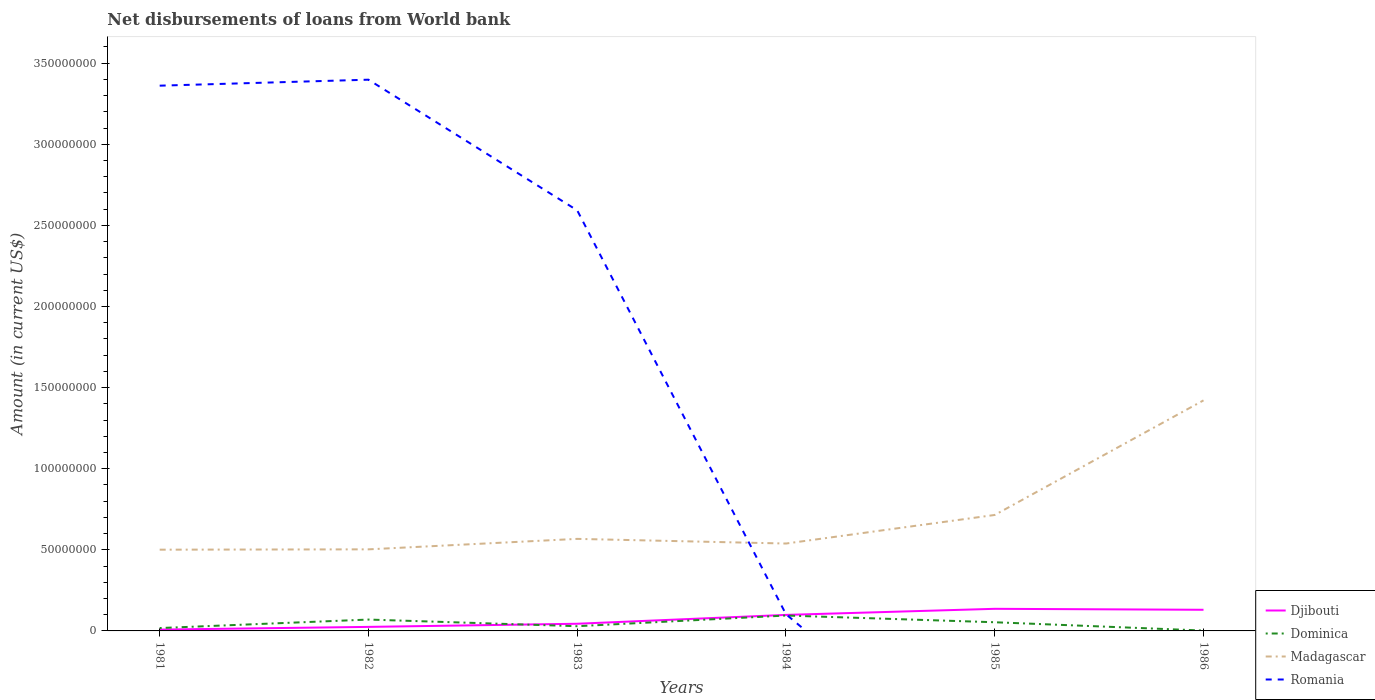Does the line corresponding to Madagascar intersect with the line corresponding to Dominica?
Keep it short and to the point. No. Is the number of lines equal to the number of legend labels?
Keep it short and to the point. No. Across all years, what is the maximum amount of loan disbursed from World Bank in Madagascar?
Give a very brief answer. 5.01e+07. What is the total amount of loan disbursed from World Bank in Dominica in the graph?
Provide a succinct answer. 2.68e+06. What is the difference between the highest and the second highest amount of loan disbursed from World Bank in Dominica?
Offer a very short reply. 9.27e+06. What is the difference between two consecutive major ticks on the Y-axis?
Your answer should be compact. 5.00e+07. Does the graph contain grids?
Your answer should be compact. No. What is the title of the graph?
Provide a short and direct response. Net disbursements of loans from World bank. What is the label or title of the X-axis?
Provide a short and direct response. Years. What is the Amount (in current US$) in Djibouti in 1981?
Keep it short and to the point. 8.20e+05. What is the Amount (in current US$) of Dominica in 1981?
Make the answer very short. 1.77e+06. What is the Amount (in current US$) in Madagascar in 1981?
Provide a succinct answer. 5.01e+07. What is the Amount (in current US$) in Romania in 1981?
Offer a terse response. 3.36e+08. What is the Amount (in current US$) in Djibouti in 1982?
Your answer should be compact. 2.48e+06. What is the Amount (in current US$) of Dominica in 1982?
Offer a terse response. 7.01e+06. What is the Amount (in current US$) of Madagascar in 1982?
Provide a short and direct response. 5.03e+07. What is the Amount (in current US$) in Romania in 1982?
Provide a short and direct response. 3.40e+08. What is the Amount (in current US$) of Djibouti in 1983?
Provide a succinct answer. 4.42e+06. What is the Amount (in current US$) in Dominica in 1983?
Give a very brief answer. 2.90e+06. What is the Amount (in current US$) of Madagascar in 1983?
Provide a short and direct response. 5.67e+07. What is the Amount (in current US$) of Romania in 1983?
Give a very brief answer. 2.59e+08. What is the Amount (in current US$) of Djibouti in 1984?
Your answer should be very brief. 9.88e+06. What is the Amount (in current US$) in Dominica in 1984?
Keep it short and to the point. 9.49e+06. What is the Amount (in current US$) of Madagascar in 1984?
Your answer should be compact. 5.39e+07. What is the Amount (in current US$) in Romania in 1984?
Offer a terse response. 1.03e+07. What is the Amount (in current US$) of Djibouti in 1985?
Your response must be concise. 1.36e+07. What is the Amount (in current US$) in Dominica in 1985?
Offer a very short reply. 5.35e+06. What is the Amount (in current US$) in Madagascar in 1985?
Offer a terse response. 7.15e+07. What is the Amount (in current US$) in Romania in 1985?
Offer a terse response. 0. What is the Amount (in current US$) of Djibouti in 1986?
Ensure brevity in your answer.  1.30e+07. What is the Amount (in current US$) of Dominica in 1986?
Make the answer very short. 2.25e+05. What is the Amount (in current US$) in Madagascar in 1986?
Your answer should be compact. 1.42e+08. Across all years, what is the maximum Amount (in current US$) in Djibouti?
Provide a short and direct response. 1.36e+07. Across all years, what is the maximum Amount (in current US$) in Dominica?
Ensure brevity in your answer.  9.49e+06. Across all years, what is the maximum Amount (in current US$) of Madagascar?
Your answer should be compact. 1.42e+08. Across all years, what is the maximum Amount (in current US$) in Romania?
Your response must be concise. 3.40e+08. Across all years, what is the minimum Amount (in current US$) of Djibouti?
Make the answer very short. 8.20e+05. Across all years, what is the minimum Amount (in current US$) in Dominica?
Make the answer very short. 2.25e+05. Across all years, what is the minimum Amount (in current US$) of Madagascar?
Keep it short and to the point. 5.01e+07. What is the total Amount (in current US$) of Djibouti in the graph?
Your answer should be very brief. 4.43e+07. What is the total Amount (in current US$) in Dominica in the graph?
Provide a succinct answer. 2.67e+07. What is the total Amount (in current US$) in Madagascar in the graph?
Ensure brevity in your answer.  4.25e+08. What is the total Amount (in current US$) in Romania in the graph?
Provide a succinct answer. 9.46e+08. What is the difference between the Amount (in current US$) of Djibouti in 1981 and that in 1982?
Ensure brevity in your answer.  -1.66e+06. What is the difference between the Amount (in current US$) of Dominica in 1981 and that in 1982?
Your answer should be compact. -5.24e+06. What is the difference between the Amount (in current US$) in Madagascar in 1981 and that in 1982?
Provide a short and direct response. -2.01e+05. What is the difference between the Amount (in current US$) of Romania in 1981 and that in 1982?
Give a very brief answer. -3.68e+06. What is the difference between the Amount (in current US$) of Djibouti in 1981 and that in 1983?
Your answer should be very brief. -3.60e+06. What is the difference between the Amount (in current US$) of Dominica in 1981 and that in 1983?
Ensure brevity in your answer.  -1.14e+06. What is the difference between the Amount (in current US$) in Madagascar in 1981 and that in 1983?
Your answer should be very brief. -6.66e+06. What is the difference between the Amount (in current US$) of Romania in 1981 and that in 1983?
Make the answer very short. 7.69e+07. What is the difference between the Amount (in current US$) in Djibouti in 1981 and that in 1984?
Your response must be concise. -9.06e+06. What is the difference between the Amount (in current US$) in Dominica in 1981 and that in 1984?
Keep it short and to the point. -7.73e+06. What is the difference between the Amount (in current US$) in Madagascar in 1981 and that in 1984?
Your response must be concise. -3.78e+06. What is the difference between the Amount (in current US$) in Romania in 1981 and that in 1984?
Your answer should be very brief. 3.26e+08. What is the difference between the Amount (in current US$) of Djibouti in 1981 and that in 1985?
Give a very brief answer. -1.28e+07. What is the difference between the Amount (in current US$) in Dominica in 1981 and that in 1985?
Your answer should be compact. -3.58e+06. What is the difference between the Amount (in current US$) of Madagascar in 1981 and that in 1985?
Provide a short and direct response. -2.14e+07. What is the difference between the Amount (in current US$) in Djibouti in 1981 and that in 1986?
Keep it short and to the point. -1.22e+07. What is the difference between the Amount (in current US$) in Dominica in 1981 and that in 1986?
Make the answer very short. 1.54e+06. What is the difference between the Amount (in current US$) of Madagascar in 1981 and that in 1986?
Your answer should be very brief. -9.20e+07. What is the difference between the Amount (in current US$) in Djibouti in 1982 and that in 1983?
Offer a terse response. -1.94e+06. What is the difference between the Amount (in current US$) of Dominica in 1982 and that in 1983?
Give a very brief answer. 4.10e+06. What is the difference between the Amount (in current US$) in Madagascar in 1982 and that in 1983?
Give a very brief answer. -6.45e+06. What is the difference between the Amount (in current US$) in Romania in 1982 and that in 1983?
Provide a short and direct response. 8.06e+07. What is the difference between the Amount (in current US$) of Djibouti in 1982 and that in 1984?
Ensure brevity in your answer.  -7.40e+06. What is the difference between the Amount (in current US$) of Dominica in 1982 and that in 1984?
Keep it short and to the point. -2.49e+06. What is the difference between the Amount (in current US$) of Madagascar in 1982 and that in 1984?
Ensure brevity in your answer.  -3.58e+06. What is the difference between the Amount (in current US$) in Romania in 1982 and that in 1984?
Provide a succinct answer. 3.30e+08. What is the difference between the Amount (in current US$) in Djibouti in 1982 and that in 1985?
Your answer should be compact. -1.11e+07. What is the difference between the Amount (in current US$) of Dominica in 1982 and that in 1985?
Keep it short and to the point. 1.66e+06. What is the difference between the Amount (in current US$) in Madagascar in 1982 and that in 1985?
Your answer should be very brief. -2.12e+07. What is the difference between the Amount (in current US$) of Djibouti in 1982 and that in 1986?
Provide a short and direct response. -1.06e+07. What is the difference between the Amount (in current US$) in Dominica in 1982 and that in 1986?
Provide a succinct answer. 6.78e+06. What is the difference between the Amount (in current US$) in Madagascar in 1982 and that in 1986?
Give a very brief answer. -9.18e+07. What is the difference between the Amount (in current US$) of Djibouti in 1983 and that in 1984?
Keep it short and to the point. -5.46e+06. What is the difference between the Amount (in current US$) in Dominica in 1983 and that in 1984?
Make the answer very short. -6.59e+06. What is the difference between the Amount (in current US$) of Madagascar in 1983 and that in 1984?
Your answer should be compact. 2.87e+06. What is the difference between the Amount (in current US$) in Romania in 1983 and that in 1984?
Your answer should be very brief. 2.49e+08. What is the difference between the Amount (in current US$) in Djibouti in 1983 and that in 1985?
Your answer should be compact. -9.21e+06. What is the difference between the Amount (in current US$) of Dominica in 1983 and that in 1985?
Your answer should be compact. -2.44e+06. What is the difference between the Amount (in current US$) of Madagascar in 1983 and that in 1985?
Your response must be concise. -1.47e+07. What is the difference between the Amount (in current US$) of Djibouti in 1983 and that in 1986?
Your answer should be compact. -8.62e+06. What is the difference between the Amount (in current US$) in Dominica in 1983 and that in 1986?
Provide a short and direct response. 2.68e+06. What is the difference between the Amount (in current US$) of Madagascar in 1983 and that in 1986?
Offer a very short reply. -8.54e+07. What is the difference between the Amount (in current US$) of Djibouti in 1984 and that in 1985?
Your answer should be very brief. -3.75e+06. What is the difference between the Amount (in current US$) of Dominica in 1984 and that in 1985?
Your answer should be very brief. 4.15e+06. What is the difference between the Amount (in current US$) in Madagascar in 1984 and that in 1985?
Ensure brevity in your answer.  -1.76e+07. What is the difference between the Amount (in current US$) in Djibouti in 1984 and that in 1986?
Ensure brevity in your answer.  -3.16e+06. What is the difference between the Amount (in current US$) of Dominica in 1984 and that in 1986?
Give a very brief answer. 9.27e+06. What is the difference between the Amount (in current US$) in Madagascar in 1984 and that in 1986?
Give a very brief answer. -8.83e+07. What is the difference between the Amount (in current US$) in Djibouti in 1985 and that in 1986?
Keep it short and to the point. 5.93e+05. What is the difference between the Amount (in current US$) in Dominica in 1985 and that in 1986?
Your response must be concise. 5.12e+06. What is the difference between the Amount (in current US$) of Madagascar in 1985 and that in 1986?
Give a very brief answer. -7.06e+07. What is the difference between the Amount (in current US$) in Djibouti in 1981 and the Amount (in current US$) in Dominica in 1982?
Provide a short and direct response. -6.19e+06. What is the difference between the Amount (in current US$) in Djibouti in 1981 and the Amount (in current US$) in Madagascar in 1982?
Provide a short and direct response. -4.95e+07. What is the difference between the Amount (in current US$) of Djibouti in 1981 and the Amount (in current US$) of Romania in 1982?
Your answer should be compact. -3.39e+08. What is the difference between the Amount (in current US$) in Dominica in 1981 and the Amount (in current US$) in Madagascar in 1982?
Your response must be concise. -4.85e+07. What is the difference between the Amount (in current US$) of Dominica in 1981 and the Amount (in current US$) of Romania in 1982?
Your answer should be compact. -3.38e+08. What is the difference between the Amount (in current US$) of Madagascar in 1981 and the Amount (in current US$) of Romania in 1982?
Provide a short and direct response. -2.90e+08. What is the difference between the Amount (in current US$) in Djibouti in 1981 and the Amount (in current US$) in Dominica in 1983?
Make the answer very short. -2.08e+06. What is the difference between the Amount (in current US$) in Djibouti in 1981 and the Amount (in current US$) in Madagascar in 1983?
Give a very brief answer. -5.59e+07. What is the difference between the Amount (in current US$) of Djibouti in 1981 and the Amount (in current US$) of Romania in 1983?
Offer a very short reply. -2.58e+08. What is the difference between the Amount (in current US$) in Dominica in 1981 and the Amount (in current US$) in Madagascar in 1983?
Provide a succinct answer. -5.50e+07. What is the difference between the Amount (in current US$) of Dominica in 1981 and the Amount (in current US$) of Romania in 1983?
Offer a terse response. -2.58e+08. What is the difference between the Amount (in current US$) in Madagascar in 1981 and the Amount (in current US$) in Romania in 1983?
Give a very brief answer. -2.09e+08. What is the difference between the Amount (in current US$) in Djibouti in 1981 and the Amount (in current US$) in Dominica in 1984?
Your answer should be compact. -8.67e+06. What is the difference between the Amount (in current US$) of Djibouti in 1981 and the Amount (in current US$) of Madagascar in 1984?
Provide a succinct answer. -5.31e+07. What is the difference between the Amount (in current US$) in Djibouti in 1981 and the Amount (in current US$) in Romania in 1984?
Your answer should be very brief. -9.47e+06. What is the difference between the Amount (in current US$) of Dominica in 1981 and the Amount (in current US$) of Madagascar in 1984?
Provide a short and direct response. -5.21e+07. What is the difference between the Amount (in current US$) of Dominica in 1981 and the Amount (in current US$) of Romania in 1984?
Offer a very short reply. -8.52e+06. What is the difference between the Amount (in current US$) in Madagascar in 1981 and the Amount (in current US$) in Romania in 1984?
Your answer should be very brief. 3.98e+07. What is the difference between the Amount (in current US$) in Djibouti in 1981 and the Amount (in current US$) in Dominica in 1985?
Your response must be concise. -4.53e+06. What is the difference between the Amount (in current US$) in Djibouti in 1981 and the Amount (in current US$) in Madagascar in 1985?
Offer a very short reply. -7.07e+07. What is the difference between the Amount (in current US$) of Dominica in 1981 and the Amount (in current US$) of Madagascar in 1985?
Keep it short and to the point. -6.97e+07. What is the difference between the Amount (in current US$) of Djibouti in 1981 and the Amount (in current US$) of Dominica in 1986?
Your answer should be very brief. 5.95e+05. What is the difference between the Amount (in current US$) of Djibouti in 1981 and the Amount (in current US$) of Madagascar in 1986?
Offer a very short reply. -1.41e+08. What is the difference between the Amount (in current US$) in Dominica in 1981 and the Amount (in current US$) in Madagascar in 1986?
Provide a short and direct response. -1.40e+08. What is the difference between the Amount (in current US$) of Djibouti in 1982 and the Amount (in current US$) of Dominica in 1983?
Your answer should be very brief. -4.23e+05. What is the difference between the Amount (in current US$) in Djibouti in 1982 and the Amount (in current US$) in Madagascar in 1983?
Ensure brevity in your answer.  -5.43e+07. What is the difference between the Amount (in current US$) of Djibouti in 1982 and the Amount (in current US$) of Romania in 1983?
Offer a very short reply. -2.57e+08. What is the difference between the Amount (in current US$) of Dominica in 1982 and the Amount (in current US$) of Madagascar in 1983?
Make the answer very short. -4.97e+07. What is the difference between the Amount (in current US$) in Dominica in 1982 and the Amount (in current US$) in Romania in 1983?
Your response must be concise. -2.52e+08. What is the difference between the Amount (in current US$) of Madagascar in 1982 and the Amount (in current US$) of Romania in 1983?
Your answer should be very brief. -2.09e+08. What is the difference between the Amount (in current US$) of Djibouti in 1982 and the Amount (in current US$) of Dominica in 1984?
Provide a succinct answer. -7.01e+06. What is the difference between the Amount (in current US$) of Djibouti in 1982 and the Amount (in current US$) of Madagascar in 1984?
Offer a terse response. -5.14e+07. What is the difference between the Amount (in current US$) of Djibouti in 1982 and the Amount (in current US$) of Romania in 1984?
Give a very brief answer. -7.80e+06. What is the difference between the Amount (in current US$) of Dominica in 1982 and the Amount (in current US$) of Madagascar in 1984?
Your answer should be compact. -4.69e+07. What is the difference between the Amount (in current US$) of Dominica in 1982 and the Amount (in current US$) of Romania in 1984?
Provide a succinct answer. -3.28e+06. What is the difference between the Amount (in current US$) of Madagascar in 1982 and the Amount (in current US$) of Romania in 1984?
Make the answer very short. 4.00e+07. What is the difference between the Amount (in current US$) of Djibouti in 1982 and the Amount (in current US$) of Dominica in 1985?
Your answer should be very brief. -2.87e+06. What is the difference between the Amount (in current US$) in Djibouti in 1982 and the Amount (in current US$) in Madagascar in 1985?
Give a very brief answer. -6.90e+07. What is the difference between the Amount (in current US$) in Dominica in 1982 and the Amount (in current US$) in Madagascar in 1985?
Give a very brief answer. -6.45e+07. What is the difference between the Amount (in current US$) in Djibouti in 1982 and the Amount (in current US$) in Dominica in 1986?
Keep it short and to the point. 2.26e+06. What is the difference between the Amount (in current US$) of Djibouti in 1982 and the Amount (in current US$) of Madagascar in 1986?
Give a very brief answer. -1.40e+08. What is the difference between the Amount (in current US$) in Dominica in 1982 and the Amount (in current US$) in Madagascar in 1986?
Offer a very short reply. -1.35e+08. What is the difference between the Amount (in current US$) in Djibouti in 1983 and the Amount (in current US$) in Dominica in 1984?
Offer a terse response. -5.08e+06. What is the difference between the Amount (in current US$) of Djibouti in 1983 and the Amount (in current US$) of Madagascar in 1984?
Your response must be concise. -4.95e+07. What is the difference between the Amount (in current US$) of Djibouti in 1983 and the Amount (in current US$) of Romania in 1984?
Your answer should be compact. -5.87e+06. What is the difference between the Amount (in current US$) of Dominica in 1983 and the Amount (in current US$) of Madagascar in 1984?
Your answer should be compact. -5.10e+07. What is the difference between the Amount (in current US$) in Dominica in 1983 and the Amount (in current US$) in Romania in 1984?
Offer a terse response. -7.38e+06. What is the difference between the Amount (in current US$) in Madagascar in 1983 and the Amount (in current US$) in Romania in 1984?
Your response must be concise. 4.65e+07. What is the difference between the Amount (in current US$) in Djibouti in 1983 and the Amount (in current US$) in Dominica in 1985?
Offer a terse response. -9.29e+05. What is the difference between the Amount (in current US$) of Djibouti in 1983 and the Amount (in current US$) of Madagascar in 1985?
Ensure brevity in your answer.  -6.71e+07. What is the difference between the Amount (in current US$) of Dominica in 1983 and the Amount (in current US$) of Madagascar in 1985?
Provide a succinct answer. -6.86e+07. What is the difference between the Amount (in current US$) in Djibouti in 1983 and the Amount (in current US$) in Dominica in 1986?
Offer a terse response. 4.19e+06. What is the difference between the Amount (in current US$) of Djibouti in 1983 and the Amount (in current US$) of Madagascar in 1986?
Ensure brevity in your answer.  -1.38e+08. What is the difference between the Amount (in current US$) in Dominica in 1983 and the Amount (in current US$) in Madagascar in 1986?
Ensure brevity in your answer.  -1.39e+08. What is the difference between the Amount (in current US$) in Djibouti in 1984 and the Amount (in current US$) in Dominica in 1985?
Keep it short and to the point. 4.53e+06. What is the difference between the Amount (in current US$) in Djibouti in 1984 and the Amount (in current US$) in Madagascar in 1985?
Your answer should be compact. -6.16e+07. What is the difference between the Amount (in current US$) of Dominica in 1984 and the Amount (in current US$) of Madagascar in 1985?
Your response must be concise. -6.20e+07. What is the difference between the Amount (in current US$) of Djibouti in 1984 and the Amount (in current US$) of Dominica in 1986?
Keep it short and to the point. 9.65e+06. What is the difference between the Amount (in current US$) of Djibouti in 1984 and the Amount (in current US$) of Madagascar in 1986?
Provide a short and direct response. -1.32e+08. What is the difference between the Amount (in current US$) in Dominica in 1984 and the Amount (in current US$) in Madagascar in 1986?
Ensure brevity in your answer.  -1.33e+08. What is the difference between the Amount (in current US$) in Djibouti in 1985 and the Amount (in current US$) in Dominica in 1986?
Offer a very short reply. 1.34e+07. What is the difference between the Amount (in current US$) of Djibouti in 1985 and the Amount (in current US$) of Madagascar in 1986?
Offer a very short reply. -1.29e+08. What is the difference between the Amount (in current US$) of Dominica in 1985 and the Amount (in current US$) of Madagascar in 1986?
Make the answer very short. -1.37e+08. What is the average Amount (in current US$) in Djibouti per year?
Ensure brevity in your answer.  7.38e+06. What is the average Amount (in current US$) in Dominica per year?
Your answer should be very brief. 4.46e+06. What is the average Amount (in current US$) of Madagascar per year?
Your answer should be compact. 7.08e+07. What is the average Amount (in current US$) in Romania per year?
Give a very brief answer. 1.58e+08. In the year 1981, what is the difference between the Amount (in current US$) in Djibouti and Amount (in current US$) in Dominica?
Offer a terse response. -9.46e+05. In the year 1981, what is the difference between the Amount (in current US$) of Djibouti and Amount (in current US$) of Madagascar?
Offer a terse response. -4.93e+07. In the year 1981, what is the difference between the Amount (in current US$) in Djibouti and Amount (in current US$) in Romania?
Ensure brevity in your answer.  -3.35e+08. In the year 1981, what is the difference between the Amount (in current US$) of Dominica and Amount (in current US$) of Madagascar?
Offer a very short reply. -4.83e+07. In the year 1981, what is the difference between the Amount (in current US$) of Dominica and Amount (in current US$) of Romania?
Your answer should be very brief. -3.34e+08. In the year 1981, what is the difference between the Amount (in current US$) in Madagascar and Amount (in current US$) in Romania?
Ensure brevity in your answer.  -2.86e+08. In the year 1982, what is the difference between the Amount (in current US$) in Djibouti and Amount (in current US$) in Dominica?
Offer a very short reply. -4.52e+06. In the year 1982, what is the difference between the Amount (in current US$) of Djibouti and Amount (in current US$) of Madagascar?
Your answer should be compact. -4.78e+07. In the year 1982, what is the difference between the Amount (in current US$) in Djibouti and Amount (in current US$) in Romania?
Your response must be concise. -3.37e+08. In the year 1982, what is the difference between the Amount (in current US$) of Dominica and Amount (in current US$) of Madagascar?
Ensure brevity in your answer.  -4.33e+07. In the year 1982, what is the difference between the Amount (in current US$) in Dominica and Amount (in current US$) in Romania?
Provide a short and direct response. -3.33e+08. In the year 1982, what is the difference between the Amount (in current US$) in Madagascar and Amount (in current US$) in Romania?
Your answer should be very brief. -2.90e+08. In the year 1983, what is the difference between the Amount (in current US$) in Djibouti and Amount (in current US$) in Dominica?
Your answer should be compact. 1.51e+06. In the year 1983, what is the difference between the Amount (in current US$) in Djibouti and Amount (in current US$) in Madagascar?
Your response must be concise. -5.23e+07. In the year 1983, what is the difference between the Amount (in current US$) in Djibouti and Amount (in current US$) in Romania?
Your answer should be compact. -2.55e+08. In the year 1983, what is the difference between the Amount (in current US$) of Dominica and Amount (in current US$) of Madagascar?
Keep it short and to the point. -5.38e+07. In the year 1983, what is the difference between the Amount (in current US$) in Dominica and Amount (in current US$) in Romania?
Offer a very short reply. -2.56e+08. In the year 1983, what is the difference between the Amount (in current US$) in Madagascar and Amount (in current US$) in Romania?
Keep it short and to the point. -2.03e+08. In the year 1984, what is the difference between the Amount (in current US$) in Djibouti and Amount (in current US$) in Dominica?
Provide a short and direct response. 3.84e+05. In the year 1984, what is the difference between the Amount (in current US$) of Djibouti and Amount (in current US$) of Madagascar?
Provide a short and direct response. -4.40e+07. In the year 1984, what is the difference between the Amount (in current US$) of Djibouti and Amount (in current US$) of Romania?
Give a very brief answer. -4.09e+05. In the year 1984, what is the difference between the Amount (in current US$) in Dominica and Amount (in current US$) in Madagascar?
Your response must be concise. -4.44e+07. In the year 1984, what is the difference between the Amount (in current US$) in Dominica and Amount (in current US$) in Romania?
Offer a terse response. -7.93e+05. In the year 1984, what is the difference between the Amount (in current US$) in Madagascar and Amount (in current US$) in Romania?
Your answer should be very brief. 4.36e+07. In the year 1985, what is the difference between the Amount (in current US$) in Djibouti and Amount (in current US$) in Dominica?
Keep it short and to the point. 8.28e+06. In the year 1985, what is the difference between the Amount (in current US$) in Djibouti and Amount (in current US$) in Madagascar?
Your response must be concise. -5.79e+07. In the year 1985, what is the difference between the Amount (in current US$) in Dominica and Amount (in current US$) in Madagascar?
Give a very brief answer. -6.61e+07. In the year 1986, what is the difference between the Amount (in current US$) of Djibouti and Amount (in current US$) of Dominica?
Your answer should be compact. 1.28e+07. In the year 1986, what is the difference between the Amount (in current US$) in Djibouti and Amount (in current US$) in Madagascar?
Give a very brief answer. -1.29e+08. In the year 1986, what is the difference between the Amount (in current US$) in Dominica and Amount (in current US$) in Madagascar?
Offer a terse response. -1.42e+08. What is the ratio of the Amount (in current US$) of Djibouti in 1981 to that in 1982?
Provide a succinct answer. 0.33. What is the ratio of the Amount (in current US$) of Dominica in 1981 to that in 1982?
Keep it short and to the point. 0.25. What is the ratio of the Amount (in current US$) of Djibouti in 1981 to that in 1983?
Make the answer very short. 0.19. What is the ratio of the Amount (in current US$) of Dominica in 1981 to that in 1983?
Provide a short and direct response. 0.61. What is the ratio of the Amount (in current US$) in Madagascar in 1981 to that in 1983?
Keep it short and to the point. 0.88. What is the ratio of the Amount (in current US$) in Romania in 1981 to that in 1983?
Your answer should be very brief. 1.3. What is the ratio of the Amount (in current US$) in Djibouti in 1981 to that in 1984?
Ensure brevity in your answer.  0.08. What is the ratio of the Amount (in current US$) in Dominica in 1981 to that in 1984?
Provide a succinct answer. 0.19. What is the ratio of the Amount (in current US$) of Madagascar in 1981 to that in 1984?
Your answer should be compact. 0.93. What is the ratio of the Amount (in current US$) of Romania in 1981 to that in 1984?
Offer a terse response. 32.68. What is the ratio of the Amount (in current US$) in Djibouti in 1981 to that in 1985?
Offer a terse response. 0.06. What is the ratio of the Amount (in current US$) of Dominica in 1981 to that in 1985?
Make the answer very short. 0.33. What is the ratio of the Amount (in current US$) in Madagascar in 1981 to that in 1985?
Keep it short and to the point. 0.7. What is the ratio of the Amount (in current US$) in Djibouti in 1981 to that in 1986?
Your response must be concise. 0.06. What is the ratio of the Amount (in current US$) of Dominica in 1981 to that in 1986?
Give a very brief answer. 7.85. What is the ratio of the Amount (in current US$) in Madagascar in 1981 to that in 1986?
Give a very brief answer. 0.35. What is the ratio of the Amount (in current US$) in Djibouti in 1982 to that in 1983?
Provide a short and direct response. 0.56. What is the ratio of the Amount (in current US$) of Dominica in 1982 to that in 1983?
Ensure brevity in your answer.  2.41. What is the ratio of the Amount (in current US$) of Madagascar in 1982 to that in 1983?
Give a very brief answer. 0.89. What is the ratio of the Amount (in current US$) in Romania in 1982 to that in 1983?
Your response must be concise. 1.31. What is the ratio of the Amount (in current US$) in Djibouti in 1982 to that in 1984?
Ensure brevity in your answer.  0.25. What is the ratio of the Amount (in current US$) of Dominica in 1982 to that in 1984?
Provide a short and direct response. 0.74. What is the ratio of the Amount (in current US$) in Madagascar in 1982 to that in 1984?
Your answer should be compact. 0.93. What is the ratio of the Amount (in current US$) of Romania in 1982 to that in 1984?
Your answer should be very brief. 33.04. What is the ratio of the Amount (in current US$) in Djibouti in 1982 to that in 1985?
Your answer should be compact. 0.18. What is the ratio of the Amount (in current US$) of Dominica in 1982 to that in 1985?
Provide a short and direct response. 1.31. What is the ratio of the Amount (in current US$) in Madagascar in 1982 to that in 1985?
Provide a succinct answer. 0.7. What is the ratio of the Amount (in current US$) of Djibouti in 1982 to that in 1986?
Your response must be concise. 0.19. What is the ratio of the Amount (in current US$) in Dominica in 1982 to that in 1986?
Provide a succinct answer. 31.14. What is the ratio of the Amount (in current US$) of Madagascar in 1982 to that in 1986?
Keep it short and to the point. 0.35. What is the ratio of the Amount (in current US$) of Djibouti in 1983 to that in 1984?
Give a very brief answer. 0.45. What is the ratio of the Amount (in current US$) of Dominica in 1983 to that in 1984?
Your answer should be compact. 0.31. What is the ratio of the Amount (in current US$) of Madagascar in 1983 to that in 1984?
Your answer should be very brief. 1.05. What is the ratio of the Amount (in current US$) of Romania in 1983 to that in 1984?
Your answer should be compact. 25.21. What is the ratio of the Amount (in current US$) of Djibouti in 1983 to that in 1985?
Make the answer very short. 0.32. What is the ratio of the Amount (in current US$) of Dominica in 1983 to that in 1985?
Your response must be concise. 0.54. What is the ratio of the Amount (in current US$) of Madagascar in 1983 to that in 1985?
Provide a succinct answer. 0.79. What is the ratio of the Amount (in current US$) in Djibouti in 1983 to that in 1986?
Give a very brief answer. 0.34. What is the ratio of the Amount (in current US$) of Dominica in 1983 to that in 1986?
Make the answer very short. 12.91. What is the ratio of the Amount (in current US$) in Madagascar in 1983 to that in 1986?
Keep it short and to the point. 0.4. What is the ratio of the Amount (in current US$) of Djibouti in 1984 to that in 1985?
Keep it short and to the point. 0.72. What is the ratio of the Amount (in current US$) in Dominica in 1984 to that in 1985?
Your answer should be very brief. 1.78. What is the ratio of the Amount (in current US$) of Madagascar in 1984 to that in 1985?
Your answer should be very brief. 0.75. What is the ratio of the Amount (in current US$) in Djibouti in 1984 to that in 1986?
Ensure brevity in your answer.  0.76. What is the ratio of the Amount (in current US$) of Dominica in 1984 to that in 1986?
Offer a terse response. 42.19. What is the ratio of the Amount (in current US$) in Madagascar in 1984 to that in 1986?
Keep it short and to the point. 0.38. What is the ratio of the Amount (in current US$) of Djibouti in 1985 to that in 1986?
Give a very brief answer. 1.05. What is the ratio of the Amount (in current US$) of Dominica in 1985 to that in 1986?
Your response must be concise. 23.76. What is the ratio of the Amount (in current US$) in Madagascar in 1985 to that in 1986?
Make the answer very short. 0.5. What is the difference between the highest and the second highest Amount (in current US$) of Djibouti?
Keep it short and to the point. 5.93e+05. What is the difference between the highest and the second highest Amount (in current US$) in Dominica?
Offer a very short reply. 2.49e+06. What is the difference between the highest and the second highest Amount (in current US$) in Madagascar?
Offer a terse response. 7.06e+07. What is the difference between the highest and the second highest Amount (in current US$) of Romania?
Offer a terse response. 3.68e+06. What is the difference between the highest and the lowest Amount (in current US$) in Djibouti?
Offer a terse response. 1.28e+07. What is the difference between the highest and the lowest Amount (in current US$) in Dominica?
Ensure brevity in your answer.  9.27e+06. What is the difference between the highest and the lowest Amount (in current US$) of Madagascar?
Offer a very short reply. 9.20e+07. What is the difference between the highest and the lowest Amount (in current US$) in Romania?
Offer a terse response. 3.40e+08. 